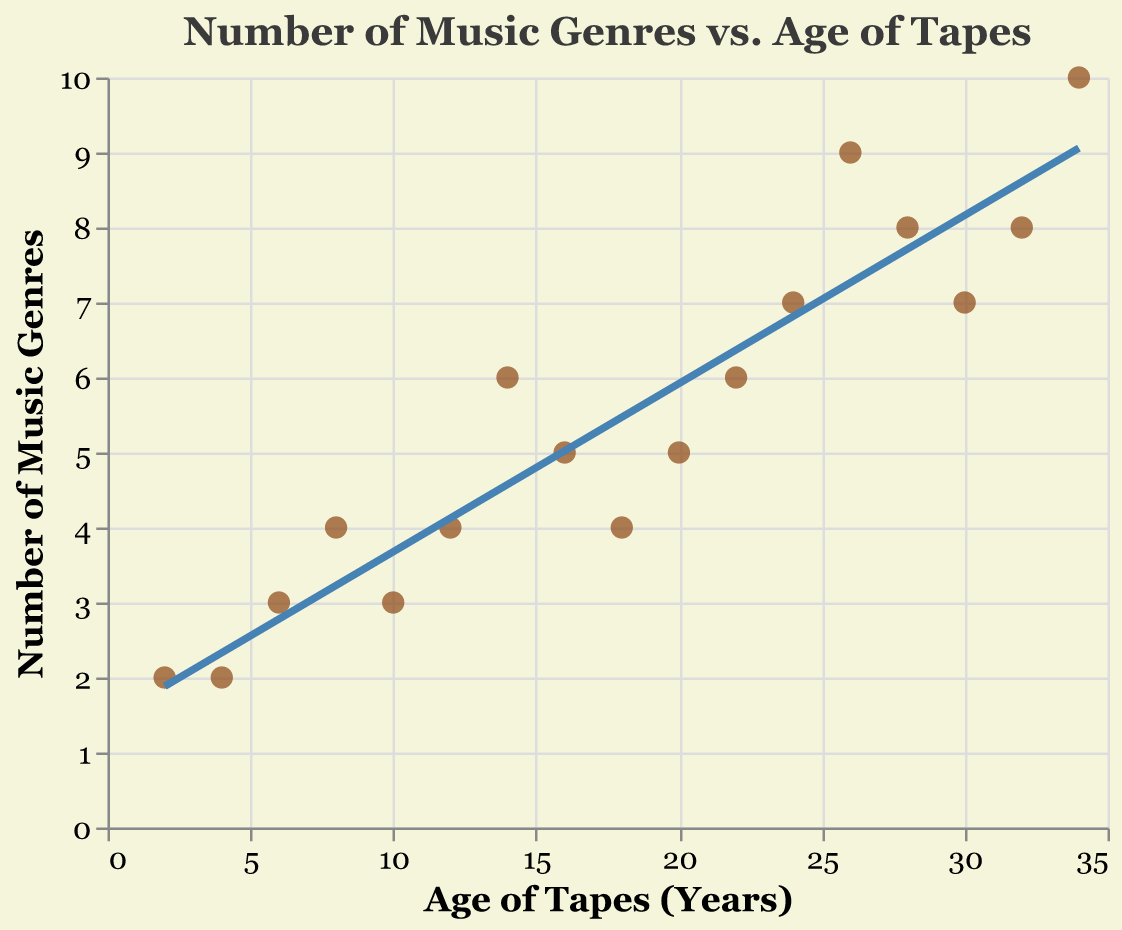What is the title of the plot? The title of the plot is given at the top of the figure. It reads "Number of Music Genres vs. Age of Tapes".
Answer: Number of Music Genres vs. Age of Tapes What does the x-axis represent? The x-axis represents the age of tapes in years. This information is provided by the label at the bottom of the x-axis, which reads "Age of Tapes (Years)".
Answer: Age of Tapes (Years) What is the color of the trend line? The trend line in the plot is colored blue. This can be identified by looking at the line that connects the data points in the plot.
Answer: Blue How many data points are plotted in the scatter plot? By counting each individual point that represents a pair of tape age and number of genres, we find there are 17 data points.
Answer: 17 What's the range of tape ages on the x-axis? The x-axis starts at 2 years and ends at 34 years. This can be observed by looking at the minimum and maximum values on the x-axis.
Answer: 2 to 34 years What's the average number of music genres for tapes that are 20 years and older? The tape ages 34, 32, 30, 28, 26, 24, and 22 have corresponding genre counts of 10, 8, 7, 8, 9, 7, and 6. To find the average: (10+8+7+8+9+7+6)/7 = 55/7 ≈ 7.86.
Answer: 7.86 Are there more data points with tape ages above or below 18 years? There are 9 data points with tape ages above 18 years (34, 32, 30, 28, 26, 24, 22, 20, 18) and 8 data points with tape ages below 18 years (16, 14, 12, 10, 8, 6, 4, 2). So, there are more data points with tape ages above 18 years.
Answer: Above 18 years Do older tapes generally have more music genres? Generally, older tapes have slightly more music genres, as indicated by the trend line which shows a slight downward slope as the tape ages increase. However, this isn't a strict rule due to some variability.
Answer: Generally, yes What is the difference in the number of genres between the oldest and the youngest tape? The oldest tape (34 years) has 10 music genres and the youngest tape (2 years) has 2 music genres. The difference is 10 - 2 = 8.
Answer: 8 What tape age has the highest number of music genres and what is that number? The tape age of 34 years has the highest number of music genres, which is 10. This can be identified by looking at the data points.
Answer: 34 years, 10 genres 